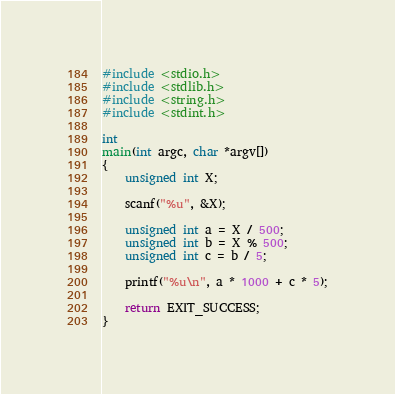Convert code to text. <code><loc_0><loc_0><loc_500><loc_500><_C_>#include <stdio.h>
#include <stdlib.h>
#include <string.h>
#include <stdint.h>

int
main(int argc, char *argv[])
{
    unsigned int X;

    scanf("%u", &X);

    unsigned int a = X / 500;
    unsigned int b = X % 500;
    unsigned int c = b / 5;

    printf("%u\n", a * 1000 + c * 5);

    return EXIT_SUCCESS;
}
</code> 